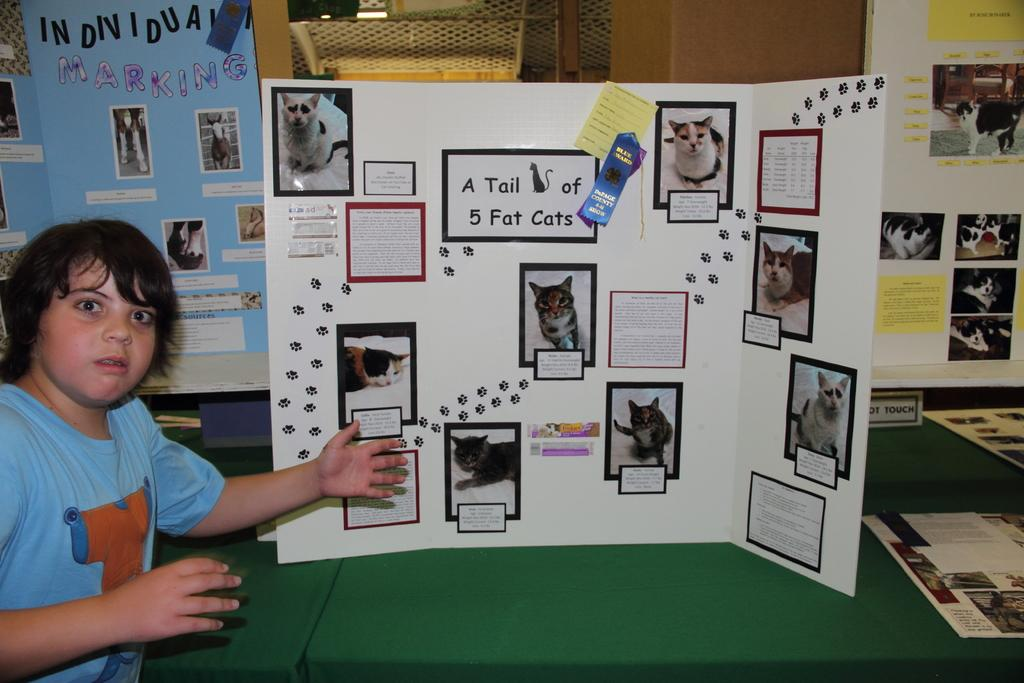<image>
Render a clear and concise summary of the photo. a boy in front of a poster titled A Tail of 5 Fat Cats 